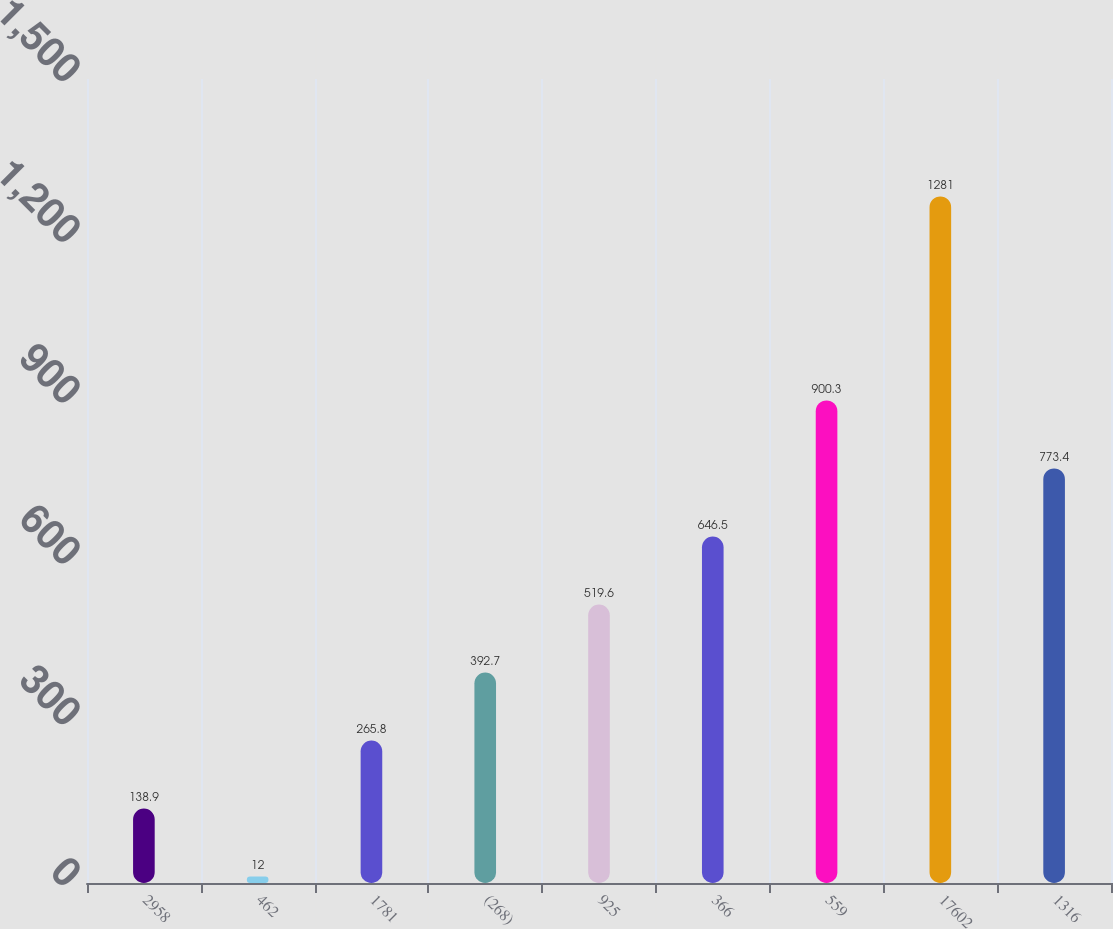<chart> <loc_0><loc_0><loc_500><loc_500><bar_chart><fcel>2958<fcel>462<fcel>1781<fcel>(268)<fcel>925<fcel>366<fcel>559<fcel>17602<fcel>1316<nl><fcel>138.9<fcel>12<fcel>265.8<fcel>392.7<fcel>519.6<fcel>646.5<fcel>900.3<fcel>1281<fcel>773.4<nl></chart> 